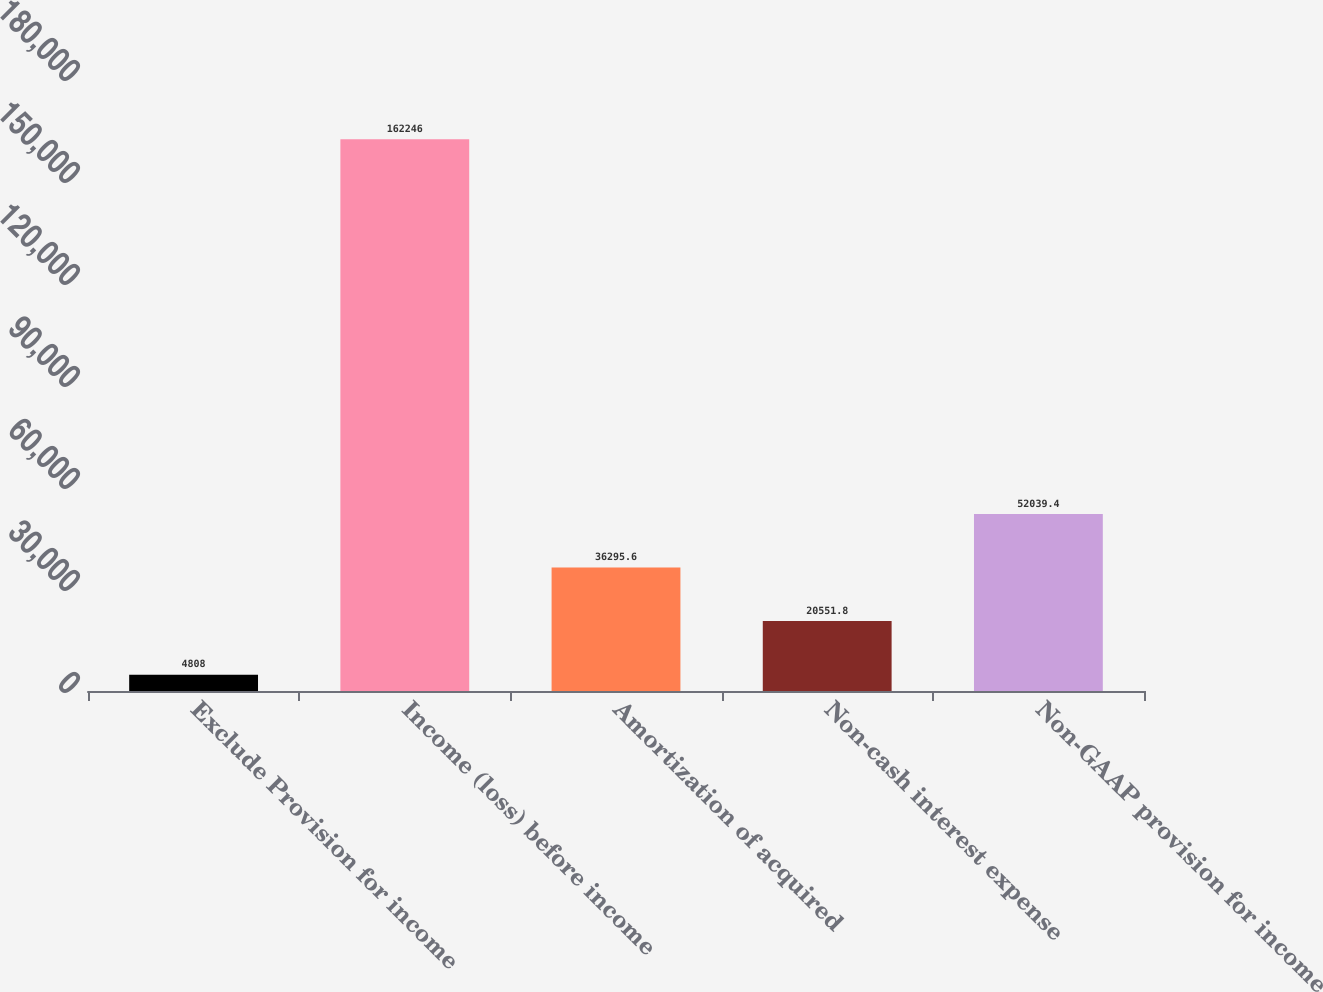<chart> <loc_0><loc_0><loc_500><loc_500><bar_chart><fcel>Exclude Provision for income<fcel>Income (loss) before income<fcel>Amortization of acquired<fcel>Non-cash interest expense<fcel>Non-GAAP provision for income<nl><fcel>4808<fcel>162246<fcel>36295.6<fcel>20551.8<fcel>52039.4<nl></chart> 